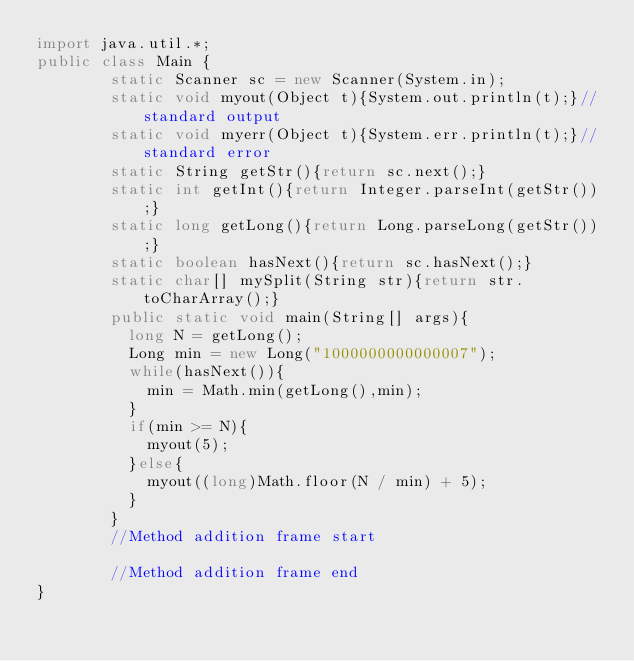Convert code to text. <code><loc_0><loc_0><loc_500><loc_500><_Java_>import java.util.*;
public class Main {
        static Scanner sc = new Scanner(System.in);
        static void myout(Object t){System.out.println(t);}//standard output
        static void myerr(Object t){System.err.println(t);}//standard error
        static String getStr(){return sc.next();}
        static int getInt(){return Integer.parseInt(getStr());}
        static long getLong(){return Long.parseLong(getStr());}
        static boolean hasNext(){return sc.hasNext();}
        static char[] mySplit(String str){return str.toCharArray();}
        public static void main(String[] args){
          long N = getLong();
          Long min = new Long("1000000000000007");
          while(hasNext()){
            min = Math.min(getLong(),min);
          }
          if(min >= N){
            myout(5);
          }else{
            myout((long)Math.floor(N / min) + 5);
          }
        }
        //Method addition frame start

        //Method addition frame end
}
</code> 